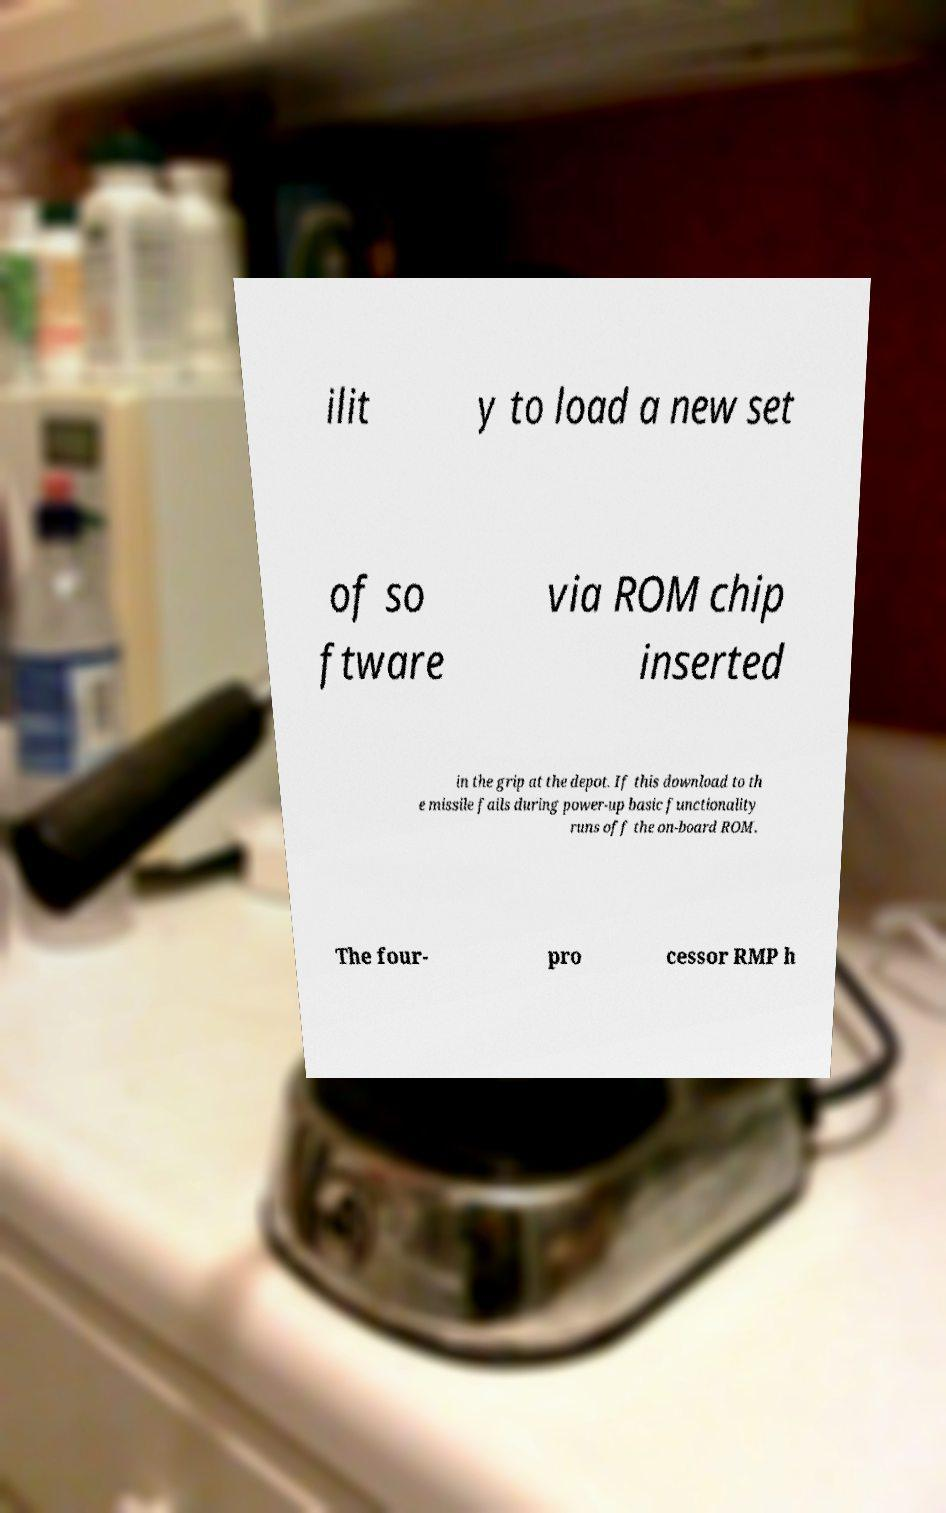Please identify and transcribe the text found in this image. ilit y to load a new set of so ftware via ROM chip inserted in the grip at the depot. If this download to th e missile fails during power-up basic functionality runs off the on-board ROM. The four- pro cessor RMP h 